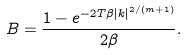Convert formula to latex. <formula><loc_0><loc_0><loc_500><loc_500>B = \frac { 1 - e ^ { - 2 T \beta | k | ^ { 2 / ( m + 1 ) } } } { 2 \beta } .</formula> 